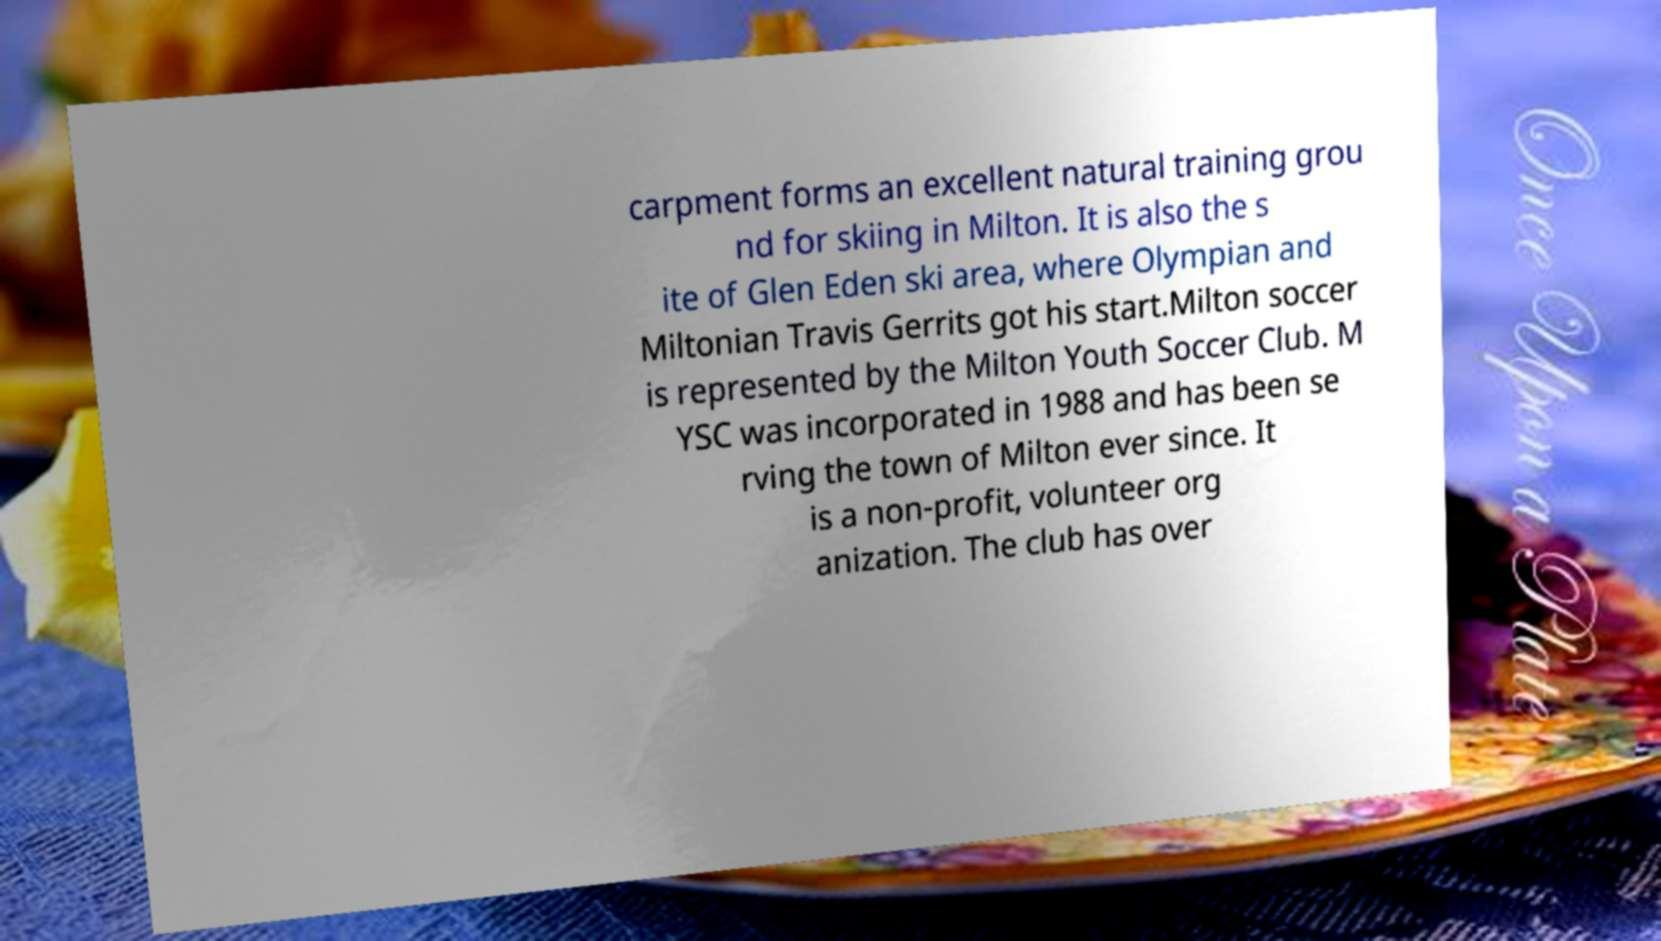There's text embedded in this image that I need extracted. Can you transcribe it verbatim? carpment forms an excellent natural training grou nd for skiing in Milton. It is also the s ite of Glen Eden ski area, where Olympian and Miltonian Travis Gerrits got his start.Milton soccer is represented by the Milton Youth Soccer Club. M YSC was incorporated in 1988 and has been se rving the town of Milton ever since. It is a non-profit, volunteer org anization. The club has over 